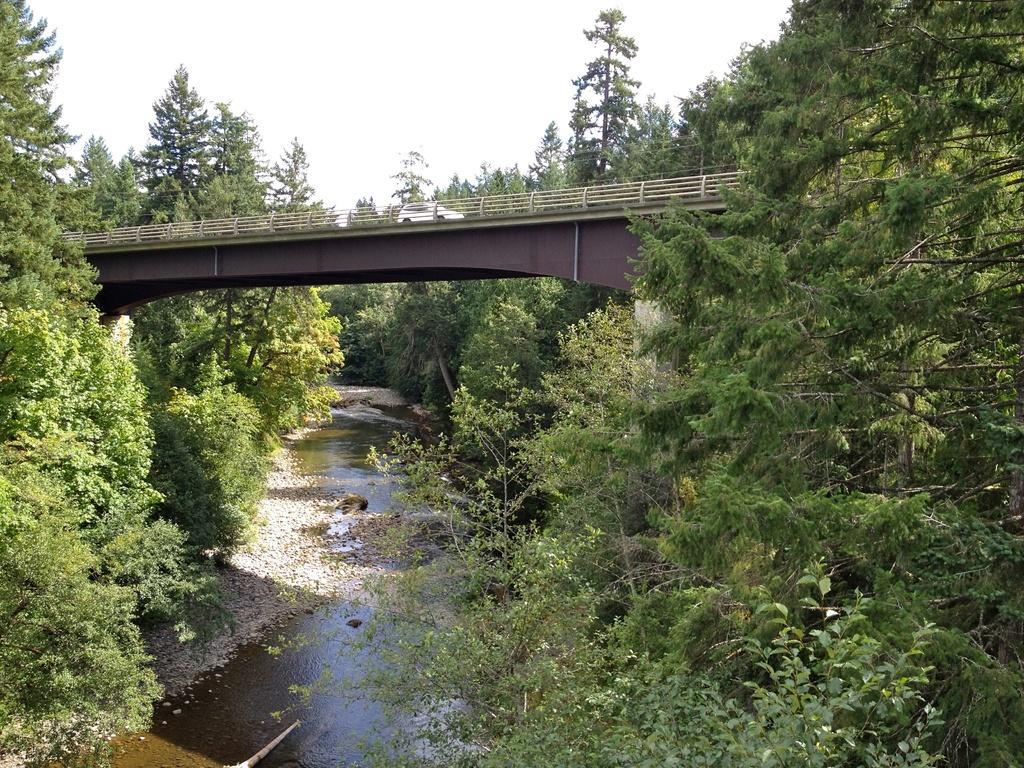Describe this image in one or two sentences. In this picture we can see trees, water and a car on the bridge and in the background we can see the sky. 